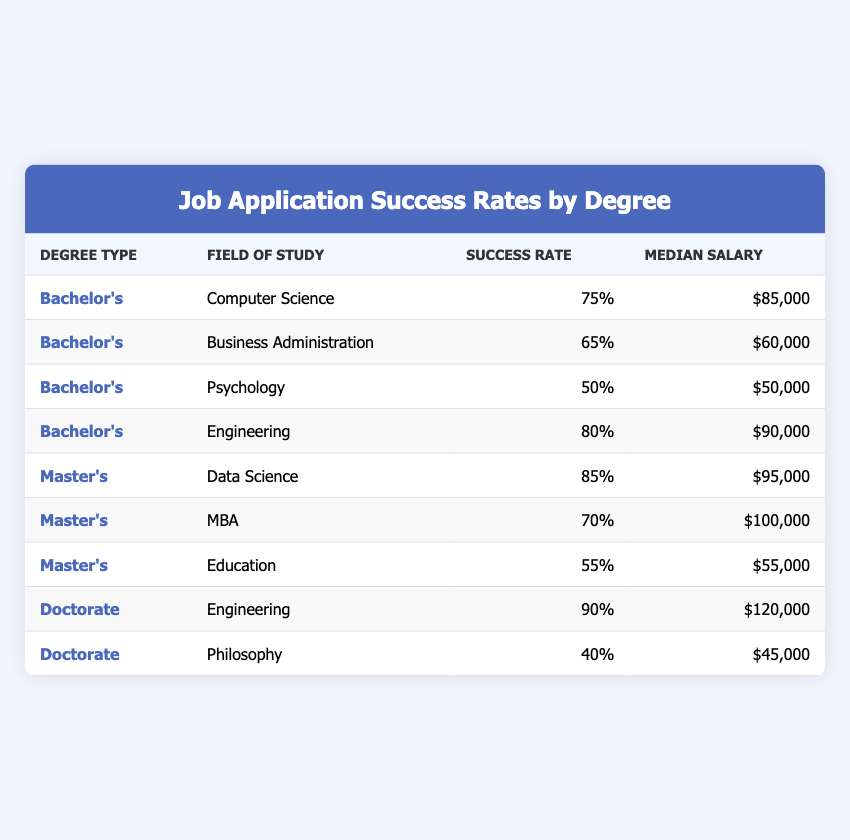What is the success rate for applicants with a Bachelor's degree in Psychology? The table indicates the success rate specifically for the field of study "Psychology" under the "Bachelor's" degree type is 50.
Answer: 50 Which degree type has the highest success rate and what is that rate? By scanning the success rates listed, the highest success rate is 90 for the "Doctorate" in "Engineering".
Answer: 90 What is the median salary for those who have a Master's degree in Education? The table shows that the median salary under the "Master's" degree type for the field "Education" is 55,000.
Answer: 55,000 What is the difference in success rates between the Master's in Data Science and the Bachelor's in Business Administration? The success rate for Master's in Data Science is 85 and for Bachelor's in Business Administration is 65. The difference is 85 - 65 = 20.
Answer: 20 Is the median salary of Doctorate degree holders generally higher than that of Bachelor's degree holders? Looking at the median salaries, Doctorates have a median salary of 120,000 (Engineering) and 45,000 (Philosophy), while the highest Bachelor's (Engineering) is 90,000 and the lowest (Psychology) is 50,000. Hence, yes, Doctorate holders generally have higher median salaries.
Answer: Yes What are the average success rates for Bachelor’s degrees and Master’s degrees combined? The success rates for Bachelor’s are 75, 65, 50, and 80, summing to 270. There are 4 Bachelor’s programs, so the average is 270/4 = 67.5. For Master’s, they are 85, 70, and 55, summing to 210. There are 3 Master’s programs, making the average 210/3 = 70. The combined average is (67.5 + 70) / 2 = 68.75.
Answer: 68.75 Which field of study has the lowest success rate overall? Examining the success rates, "Philosophy" under the Doctorate holds the lowest rate at 40.
Answer: 40 How many degree types have a success rate of 70 or higher? The fields with success rates of 70 or higher are: Data Science (85), Engineering (80), and Doctorate in Engineering (90). Thus, 4 fields achieve this threshold.
Answer: 4 What is the median salary of the field with the second-highest success rate? The field with the second-highest success rate is "Master's in MBA" at 70. The median salary for MBA is 100,000.
Answer: 100,000 